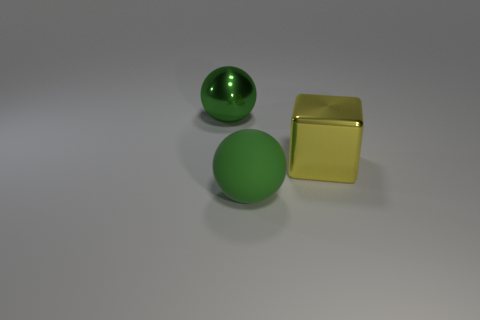Add 1 green matte balls. How many objects exist? 4 Subtract all blocks. How many objects are left? 2 Add 3 yellow cubes. How many yellow cubes are left? 4 Add 3 large gray shiny spheres. How many large gray shiny spheres exist? 3 Subtract 0 blue spheres. How many objects are left? 3 Subtract all big brown metal objects. Subtract all big shiny balls. How many objects are left? 2 